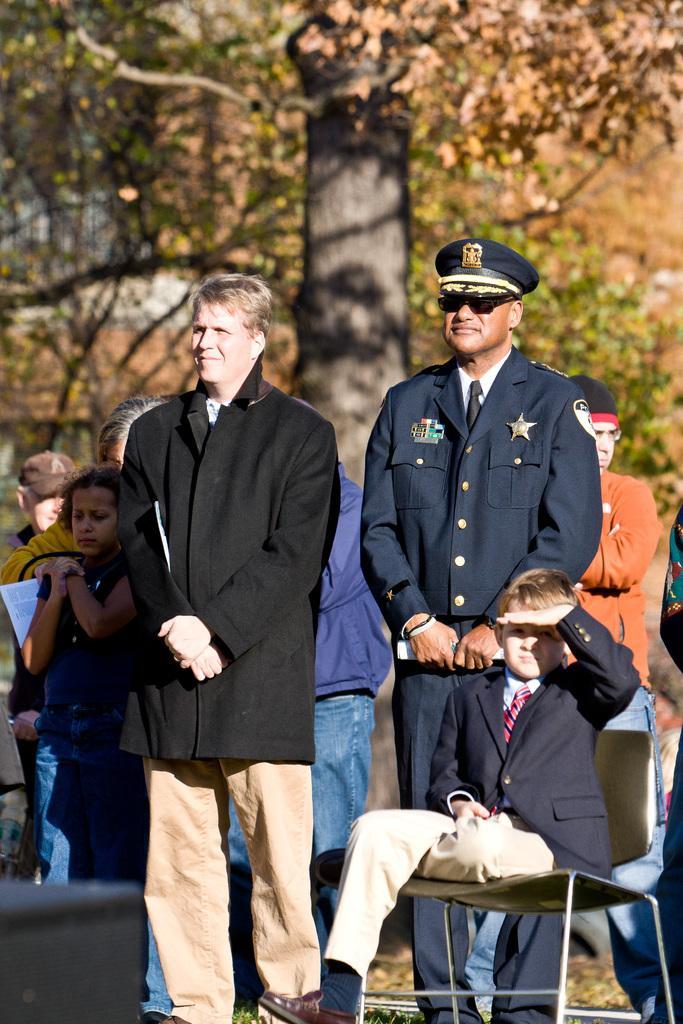Can you describe this image briefly? In this picture there are people standing and there is a boy sitting on a chair. In the background of the image we can see trees. 